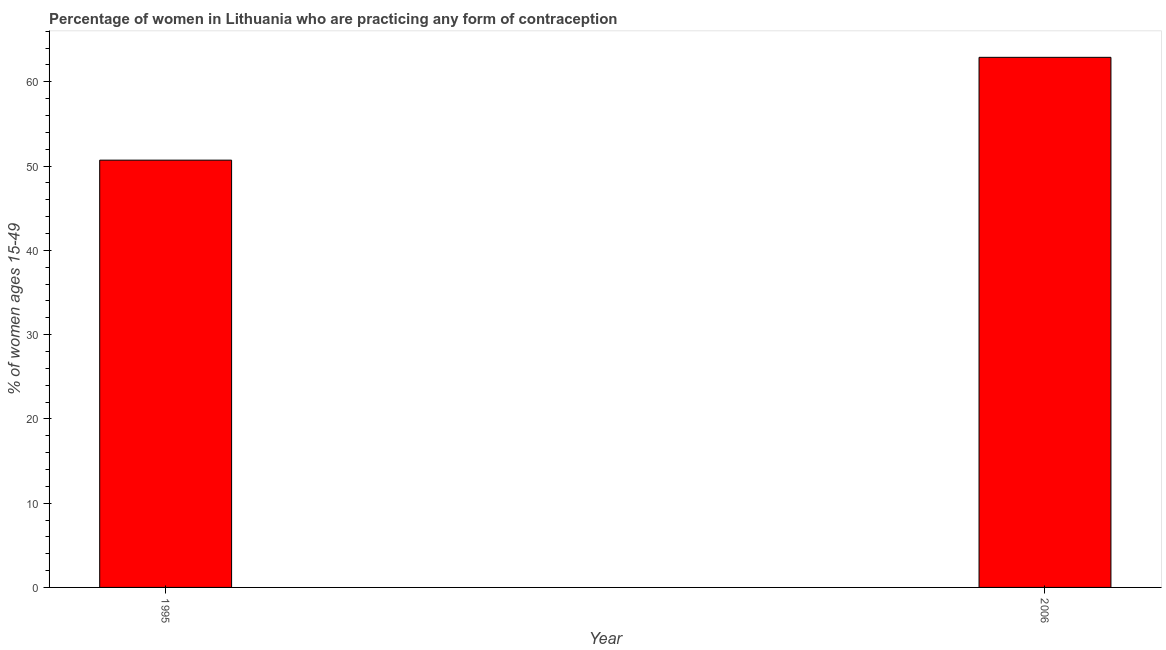Does the graph contain grids?
Provide a short and direct response. No. What is the title of the graph?
Your answer should be very brief. Percentage of women in Lithuania who are practicing any form of contraception. What is the label or title of the X-axis?
Provide a succinct answer. Year. What is the label or title of the Y-axis?
Make the answer very short. % of women ages 15-49. What is the contraceptive prevalence in 2006?
Offer a terse response. 62.9. Across all years, what is the maximum contraceptive prevalence?
Offer a very short reply. 62.9. Across all years, what is the minimum contraceptive prevalence?
Make the answer very short. 50.7. In which year was the contraceptive prevalence maximum?
Provide a succinct answer. 2006. What is the sum of the contraceptive prevalence?
Make the answer very short. 113.6. What is the difference between the contraceptive prevalence in 1995 and 2006?
Offer a terse response. -12.2. What is the average contraceptive prevalence per year?
Ensure brevity in your answer.  56.8. What is the median contraceptive prevalence?
Ensure brevity in your answer.  56.8. In how many years, is the contraceptive prevalence greater than 46 %?
Make the answer very short. 2. What is the ratio of the contraceptive prevalence in 1995 to that in 2006?
Your answer should be compact. 0.81. Are the values on the major ticks of Y-axis written in scientific E-notation?
Offer a very short reply. No. What is the % of women ages 15-49 in 1995?
Keep it short and to the point. 50.7. What is the % of women ages 15-49 of 2006?
Provide a short and direct response. 62.9. What is the difference between the % of women ages 15-49 in 1995 and 2006?
Ensure brevity in your answer.  -12.2. What is the ratio of the % of women ages 15-49 in 1995 to that in 2006?
Your response must be concise. 0.81. 